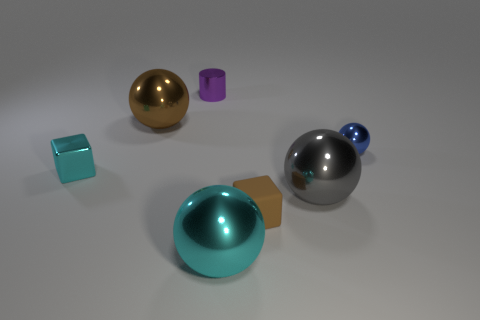Subtract all blue spheres. How many spheres are left? 3 Subtract all big gray shiny spheres. How many spheres are left? 3 Add 2 brown matte cubes. How many objects exist? 9 Subtract all purple balls. Subtract all cyan cylinders. How many balls are left? 4 Subtract all balls. How many objects are left? 3 Subtract all large brown shiny things. Subtract all small purple cylinders. How many objects are left? 5 Add 2 large brown objects. How many large brown objects are left? 3 Add 6 cyan blocks. How many cyan blocks exist? 7 Subtract 0 blue cylinders. How many objects are left? 7 